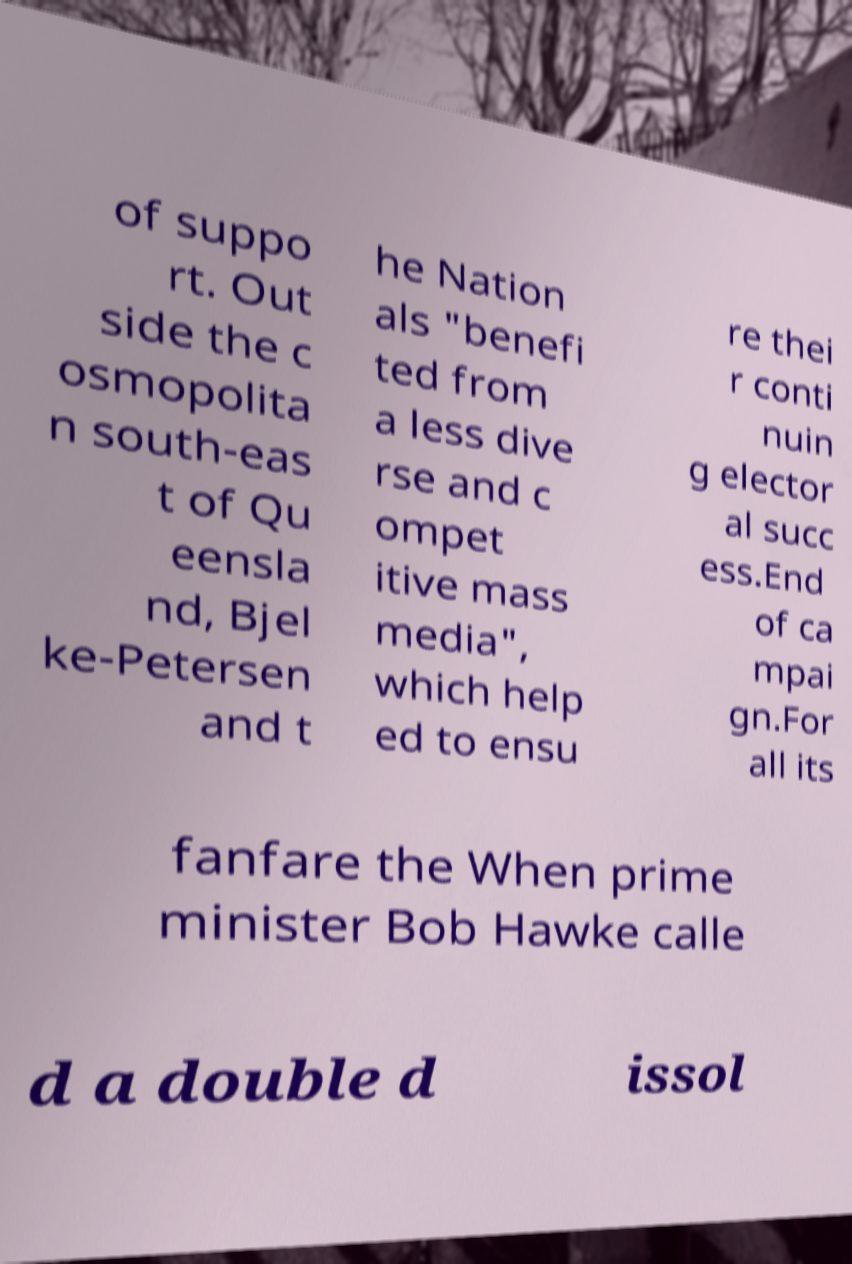There's text embedded in this image that I need extracted. Can you transcribe it verbatim? of suppo rt. Out side the c osmopolita n south-eas t of Qu eensla nd, Bjel ke-Petersen and t he Nation als "benefi ted from a less dive rse and c ompet itive mass media", which help ed to ensu re thei r conti nuin g elector al succ ess.End of ca mpai gn.For all its fanfare the When prime minister Bob Hawke calle d a double d issol 